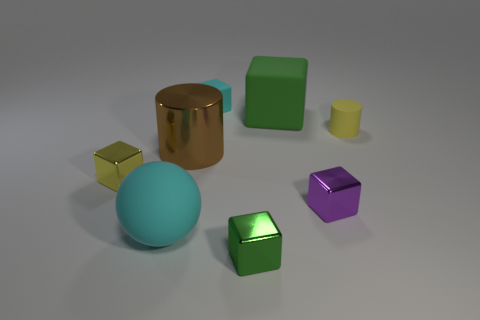Subtract all cyan cubes. How many cubes are left? 4 Subtract all yellow blocks. How many blocks are left? 4 Subtract all cylinders. How many objects are left? 6 Subtract 1 spheres. How many spheres are left? 0 Add 2 big green blocks. How many objects exist? 10 Subtract 0 gray balls. How many objects are left? 8 Subtract all brown balls. Subtract all cyan cylinders. How many balls are left? 1 Subtract all brown blocks. How many green balls are left? 0 Subtract all gray rubber cylinders. Subtract all large green matte blocks. How many objects are left? 7 Add 7 small yellow cylinders. How many small yellow cylinders are left? 8 